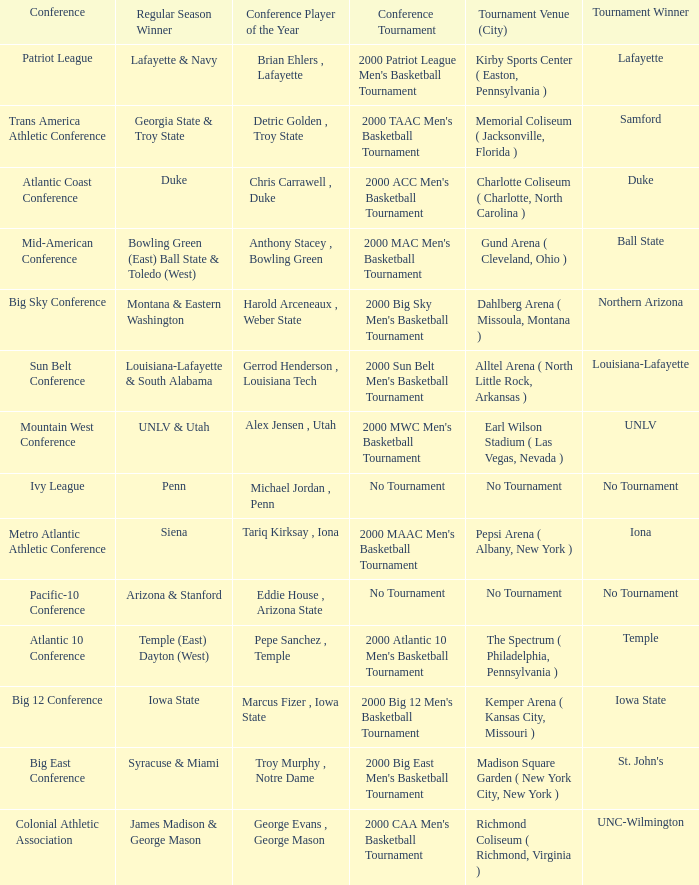How many players of the year are there in the Mountain West Conference? 1.0. 